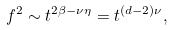<formula> <loc_0><loc_0><loc_500><loc_500>f ^ { 2 } \sim t ^ { 2 \beta - \nu \eta } = t ^ { ( d - 2 ) \nu } ,</formula> 